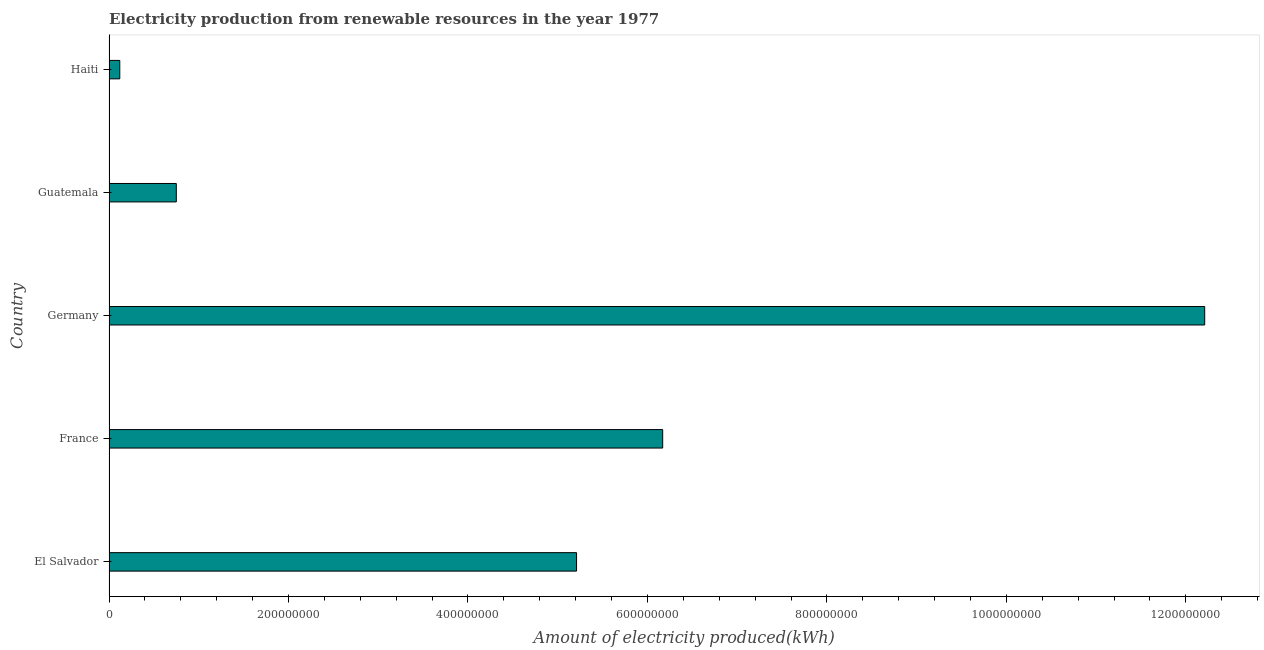Does the graph contain grids?
Your answer should be compact. No. What is the title of the graph?
Keep it short and to the point. Electricity production from renewable resources in the year 1977. What is the label or title of the X-axis?
Make the answer very short. Amount of electricity produced(kWh). What is the amount of electricity produced in Germany?
Offer a terse response. 1.22e+09. Across all countries, what is the maximum amount of electricity produced?
Offer a very short reply. 1.22e+09. Across all countries, what is the minimum amount of electricity produced?
Provide a succinct answer. 1.20e+07. In which country was the amount of electricity produced minimum?
Your answer should be compact. Haiti. What is the sum of the amount of electricity produced?
Offer a terse response. 2.45e+09. What is the difference between the amount of electricity produced in France and Haiti?
Your answer should be compact. 6.05e+08. What is the average amount of electricity produced per country?
Keep it short and to the point. 4.89e+08. What is the median amount of electricity produced?
Provide a succinct answer. 5.21e+08. In how many countries, is the amount of electricity produced greater than 1240000000 kWh?
Your answer should be compact. 0. What is the ratio of the amount of electricity produced in El Salvador to that in Haiti?
Make the answer very short. 43.42. Is the difference between the amount of electricity produced in El Salvador and Germany greater than the difference between any two countries?
Your answer should be compact. No. What is the difference between the highest and the second highest amount of electricity produced?
Provide a succinct answer. 6.04e+08. Is the sum of the amount of electricity produced in El Salvador and Haiti greater than the maximum amount of electricity produced across all countries?
Your response must be concise. No. What is the difference between the highest and the lowest amount of electricity produced?
Give a very brief answer. 1.21e+09. In how many countries, is the amount of electricity produced greater than the average amount of electricity produced taken over all countries?
Provide a short and direct response. 3. How many bars are there?
Offer a terse response. 5. Are the values on the major ticks of X-axis written in scientific E-notation?
Offer a terse response. No. What is the Amount of electricity produced(kWh) in El Salvador?
Make the answer very short. 5.21e+08. What is the Amount of electricity produced(kWh) in France?
Ensure brevity in your answer.  6.17e+08. What is the Amount of electricity produced(kWh) in Germany?
Your answer should be compact. 1.22e+09. What is the Amount of electricity produced(kWh) of Guatemala?
Your answer should be very brief. 7.50e+07. What is the difference between the Amount of electricity produced(kWh) in El Salvador and France?
Offer a very short reply. -9.60e+07. What is the difference between the Amount of electricity produced(kWh) in El Salvador and Germany?
Your answer should be compact. -7.00e+08. What is the difference between the Amount of electricity produced(kWh) in El Salvador and Guatemala?
Ensure brevity in your answer.  4.46e+08. What is the difference between the Amount of electricity produced(kWh) in El Salvador and Haiti?
Give a very brief answer. 5.09e+08. What is the difference between the Amount of electricity produced(kWh) in France and Germany?
Your answer should be compact. -6.04e+08. What is the difference between the Amount of electricity produced(kWh) in France and Guatemala?
Give a very brief answer. 5.42e+08. What is the difference between the Amount of electricity produced(kWh) in France and Haiti?
Offer a terse response. 6.05e+08. What is the difference between the Amount of electricity produced(kWh) in Germany and Guatemala?
Your answer should be compact. 1.15e+09. What is the difference between the Amount of electricity produced(kWh) in Germany and Haiti?
Make the answer very short. 1.21e+09. What is the difference between the Amount of electricity produced(kWh) in Guatemala and Haiti?
Make the answer very short. 6.30e+07. What is the ratio of the Amount of electricity produced(kWh) in El Salvador to that in France?
Provide a succinct answer. 0.84. What is the ratio of the Amount of electricity produced(kWh) in El Salvador to that in Germany?
Keep it short and to the point. 0.43. What is the ratio of the Amount of electricity produced(kWh) in El Salvador to that in Guatemala?
Provide a succinct answer. 6.95. What is the ratio of the Amount of electricity produced(kWh) in El Salvador to that in Haiti?
Make the answer very short. 43.42. What is the ratio of the Amount of electricity produced(kWh) in France to that in Germany?
Ensure brevity in your answer.  0.51. What is the ratio of the Amount of electricity produced(kWh) in France to that in Guatemala?
Provide a short and direct response. 8.23. What is the ratio of the Amount of electricity produced(kWh) in France to that in Haiti?
Your answer should be compact. 51.42. What is the ratio of the Amount of electricity produced(kWh) in Germany to that in Guatemala?
Provide a short and direct response. 16.28. What is the ratio of the Amount of electricity produced(kWh) in Germany to that in Haiti?
Keep it short and to the point. 101.75. What is the ratio of the Amount of electricity produced(kWh) in Guatemala to that in Haiti?
Ensure brevity in your answer.  6.25. 